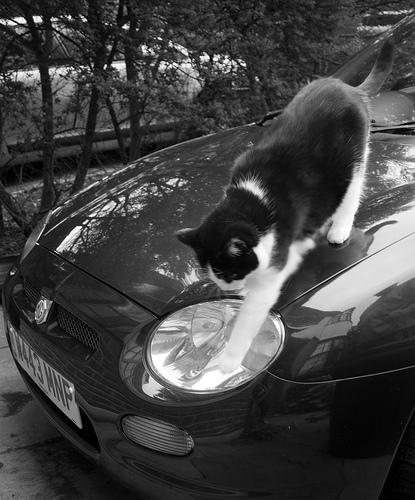Summarize the content of the image in one sentence. The image displays a black and white cat resting on a car, with its paw on the headlight. Describe the key element in the image and the setting in which it is located. A black and white cat with its front paw stretched out is sitting on a shiny car in a parking area. Identify the central focus of the image and a distinctive attribute associated with it. The central focus is a black and white cat with a stretched-out paw, sitting on a shiny car. Write a concise description of the primary subject in the image and its surroundings. A black and white cat is positioned on a shiny car with a visible license plate and emblem. Provide a brief summary of the most notable features captured in the image. The image features a black and white cat sitting on a car with a visible emblem, license plate, and reflection. State the two most prominent elements in the image and their association. A cat with a stretched-out paw is sitting on the hood of a shiny car. Provide a brief description of the main items captured in the image. The image shows a black and white cat on a shiny car with a visible emblem and license plate. Mention the primary object depicted in the image and specify its unique characteristic. A black and white cat with its front paw stretched out is sitting on the car hood. What is the main action taking place in the image? A cat with a stretched-out paw is sitting on a car with a clear reflection of its surroundings. Mention one feature of the cat and its location in the image. The cat is black and white and is sitting on the car hood with its paw on the headlight. 